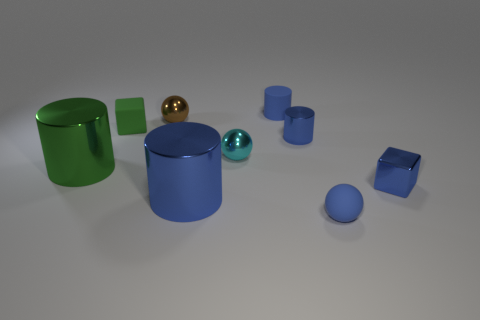Subtract all blue balls. How many blue cylinders are left? 3 Subtract all spheres. How many objects are left? 6 Add 6 green metallic objects. How many green metallic objects are left? 7 Add 1 brown spheres. How many brown spheres exist? 2 Subtract 0 purple cubes. How many objects are left? 9 Subtract all rubber cylinders. Subtract all red objects. How many objects are left? 8 